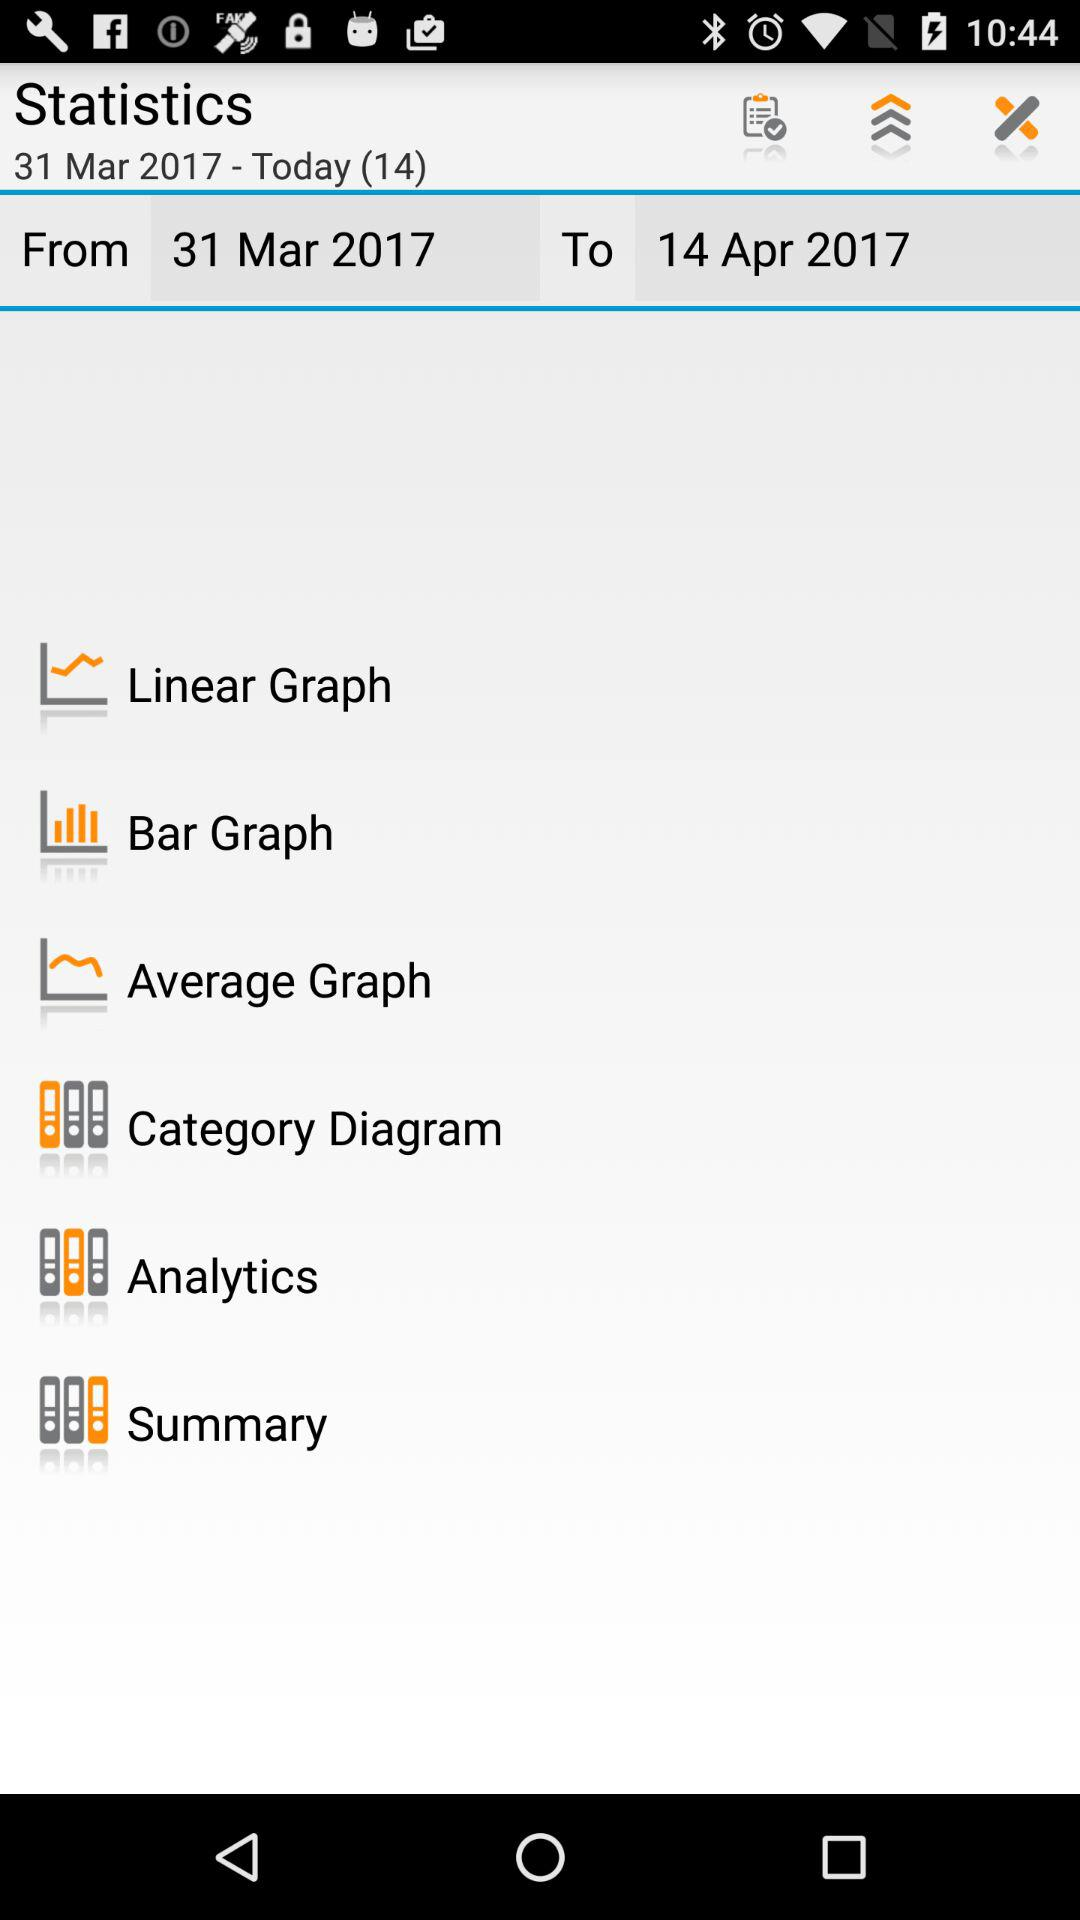What is the name of the application? The name of the application is "Statistics". 